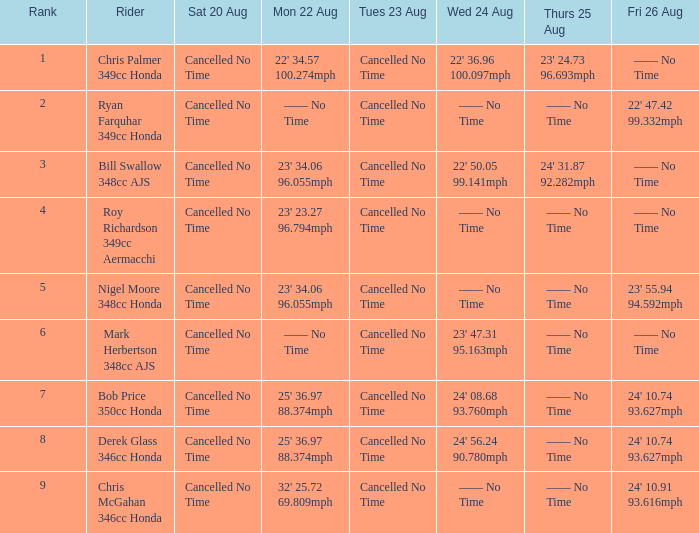What are the entire values on thursday, august 25th for ranking 3? 24' 31.87 92.282mph. 